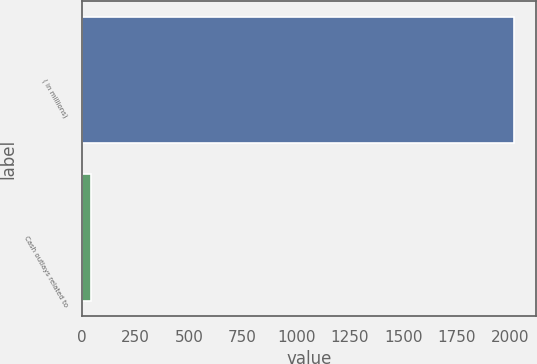Convert chart to OTSL. <chart><loc_0><loc_0><loc_500><loc_500><bar_chart><fcel>( in millions)<fcel>Cash outlays related to<nl><fcel>2017<fcel>44<nl></chart> 